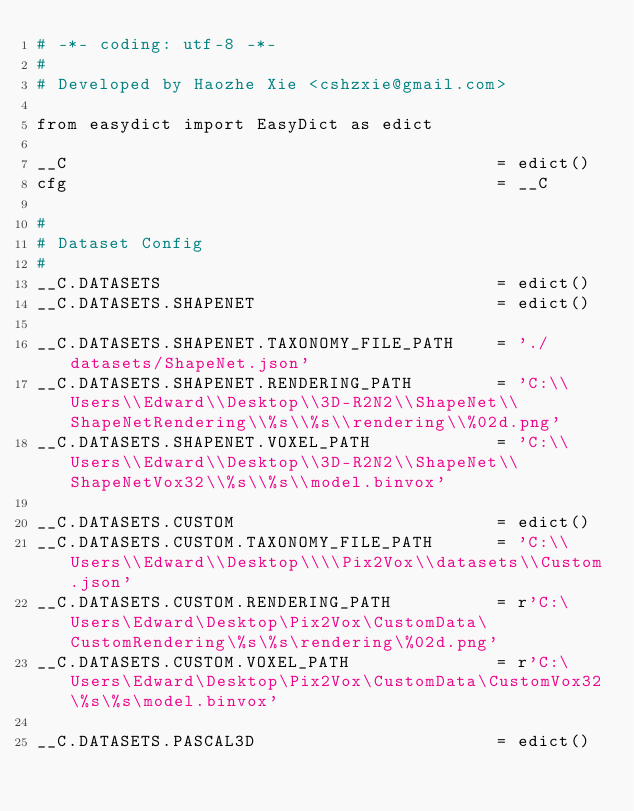Convert code to text. <code><loc_0><loc_0><loc_500><loc_500><_Python_># -*- coding: utf-8 -*-
# 
# Developed by Haozhe Xie <cshzxie@gmail.com>

from easydict import EasyDict as edict

__C                                         = edict()
cfg                                         = __C

#
# Dataset Config
#
__C.DATASETS                                = edict()
__C.DATASETS.SHAPENET                       = edict()

__C.DATASETS.SHAPENET.TAXONOMY_FILE_PATH    = './datasets/ShapeNet.json'
__C.DATASETS.SHAPENET.RENDERING_PATH        = 'C:\\Users\\Edward\\Desktop\\3D-R2N2\\ShapeNet\\ShapeNetRendering\\%s\\%s\\rendering\\%02d.png'
__C.DATASETS.SHAPENET.VOXEL_PATH            = 'C:\\Users\\Edward\\Desktop\\3D-R2N2\\ShapeNet\\ShapeNetVox32\\%s\\%s\\model.binvox'

__C.DATASETS.CUSTOM                         = edict()
__C.DATASETS.CUSTOM.TAXONOMY_FILE_PATH      = 'C:\\Users\\Edward\\Desktop\\\\Pix2Vox\\datasets\\Custom.json'
__C.DATASETS.CUSTOM.RENDERING_PATH          = r'C:\Users\Edward\Desktop\Pix2Vox\CustomData\CustomRendering\%s\%s\rendering\%02d.png'
__C.DATASETS.CUSTOM.VOXEL_PATH              = r'C:\Users\Edward\Desktop\Pix2Vox\CustomData\CustomVox32\%s\%s\model.binvox'

__C.DATASETS.PASCAL3D                       = edict()</code> 